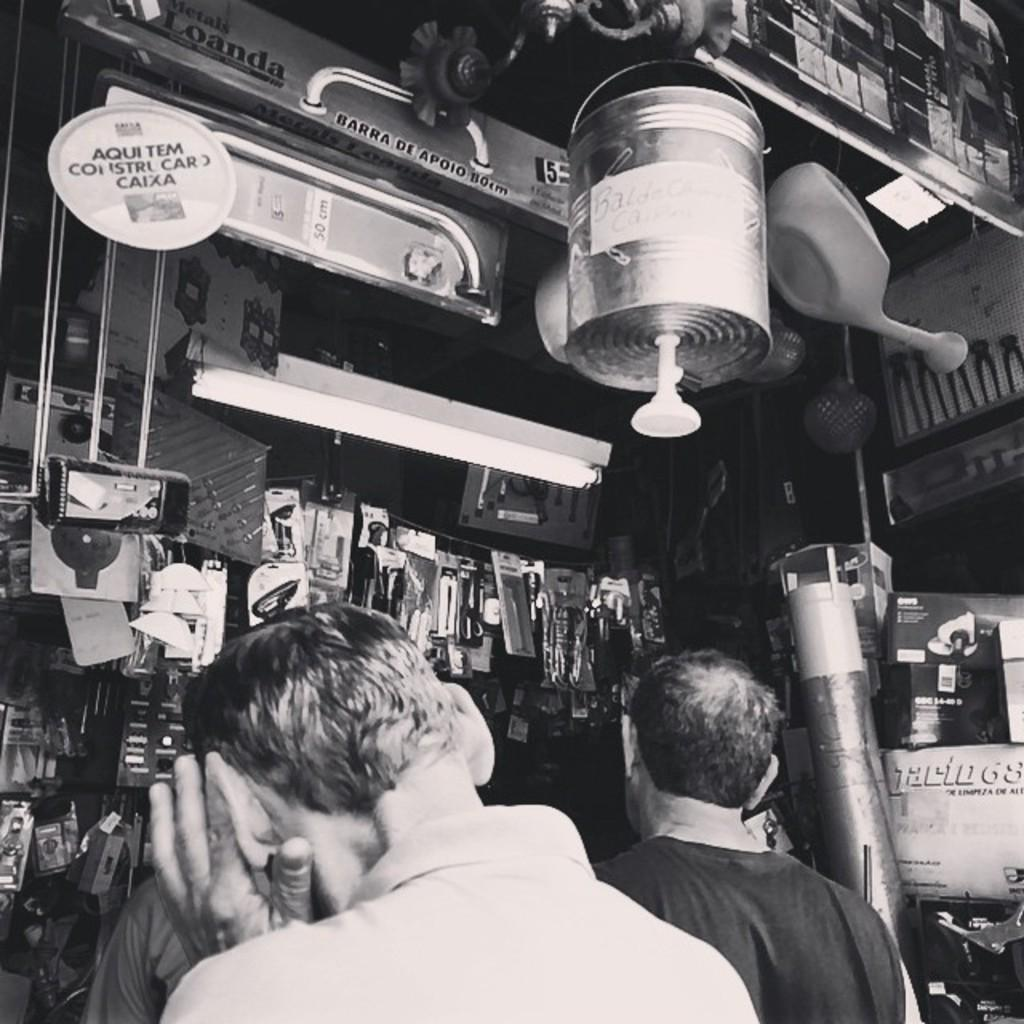How many people are present in the image? There are three people in the image. What can be seen in the background of the image? There is a tube light, posters, and unspecified objects in the background of the image. What type of ship can be seen in the aftermath of the image? There is no ship present in the image, nor is there any mention of an aftermath. 